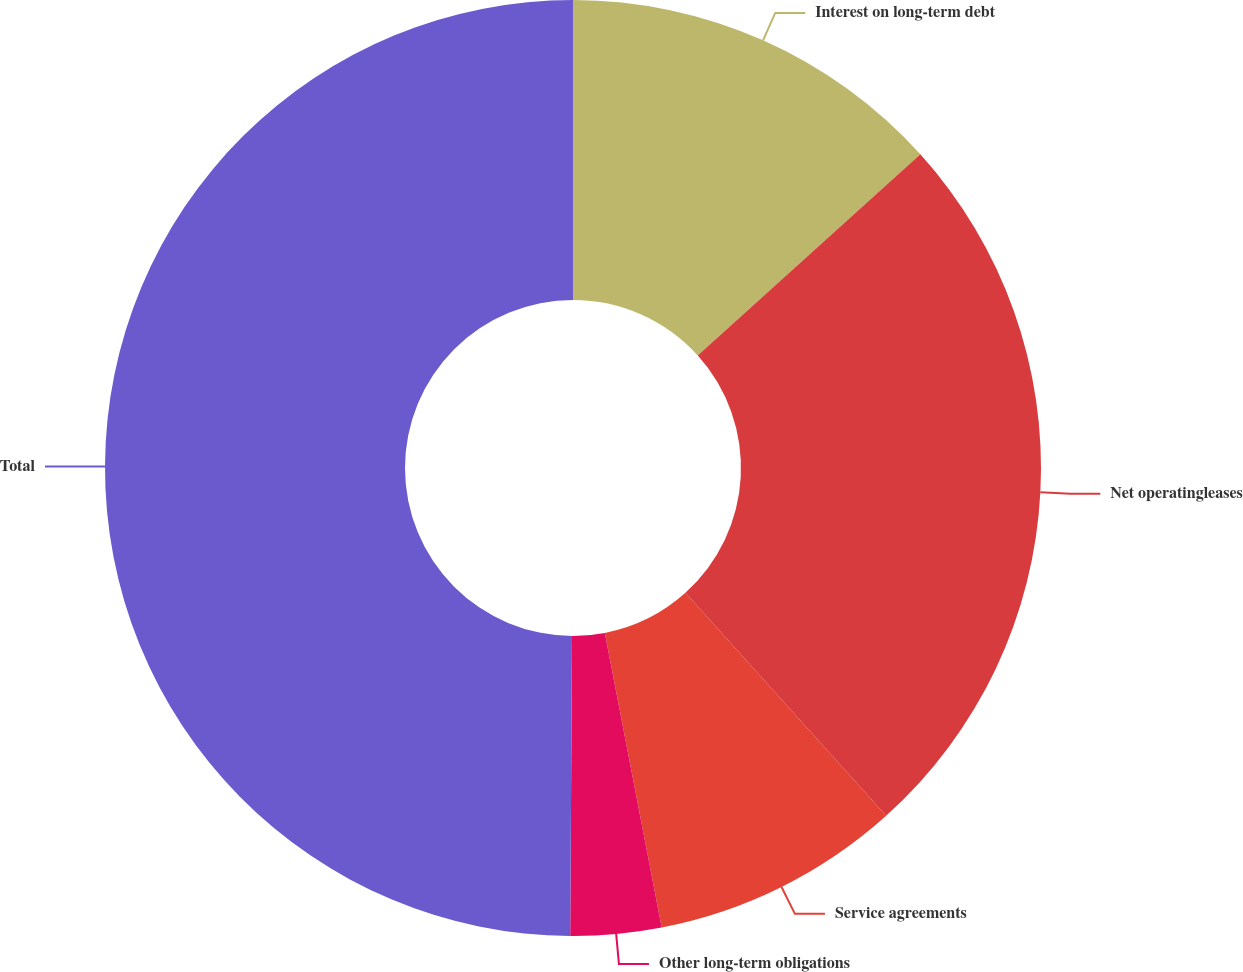Convert chart to OTSL. <chart><loc_0><loc_0><loc_500><loc_500><pie_chart><fcel>Interest on long-term debt<fcel>Net operatingleases<fcel>Service agreements<fcel>Other long-term obligations<fcel>Total<nl><fcel>13.31%<fcel>25.02%<fcel>8.63%<fcel>3.13%<fcel>49.9%<nl></chart> 